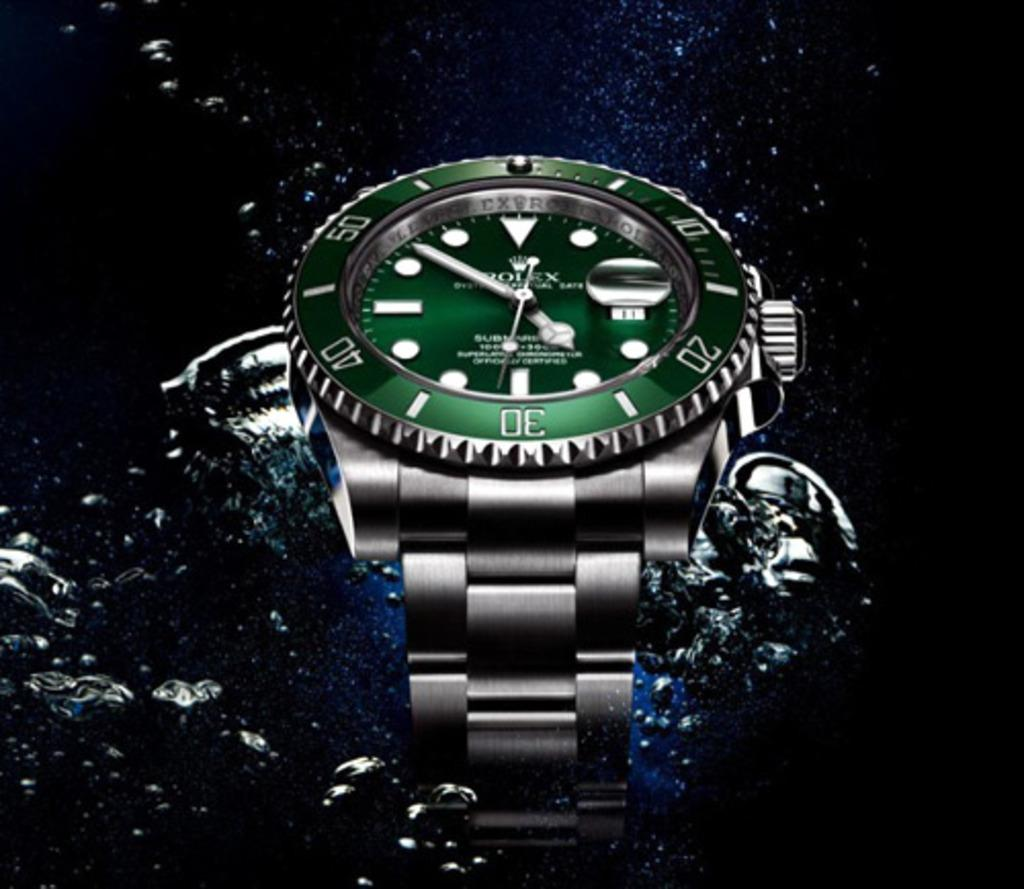<image>
Render a clear and concise summary of the photo. The Rolex watch has a bevelled edge on it. 